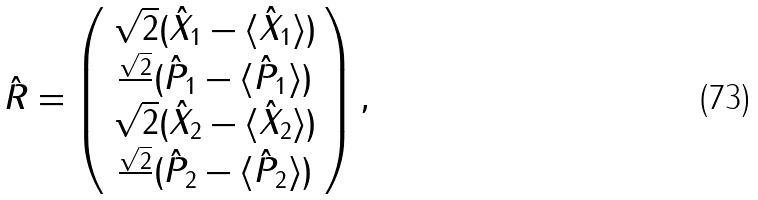Convert formula to latex. <formula><loc_0><loc_0><loc_500><loc_500>\hat { R } = \left ( \begin{array} { c } \sqrt { 2 } ( \hat { X } _ { 1 } - \langle \hat { X } _ { 1 } \rangle ) \\ \frac { \sqrt { 2 } } { } ( \hat { P } _ { 1 } - \langle \hat { P } _ { 1 } \rangle ) \\ \sqrt { 2 } ( \hat { X } _ { 2 } - \langle \hat { X } _ { 2 } \rangle ) \\ \frac { \sqrt { 2 } } { } ( \hat { P } _ { 2 } - \langle \hat { P } _ { 2 } \rangle ) \end{array} \right ) ,</formula> 